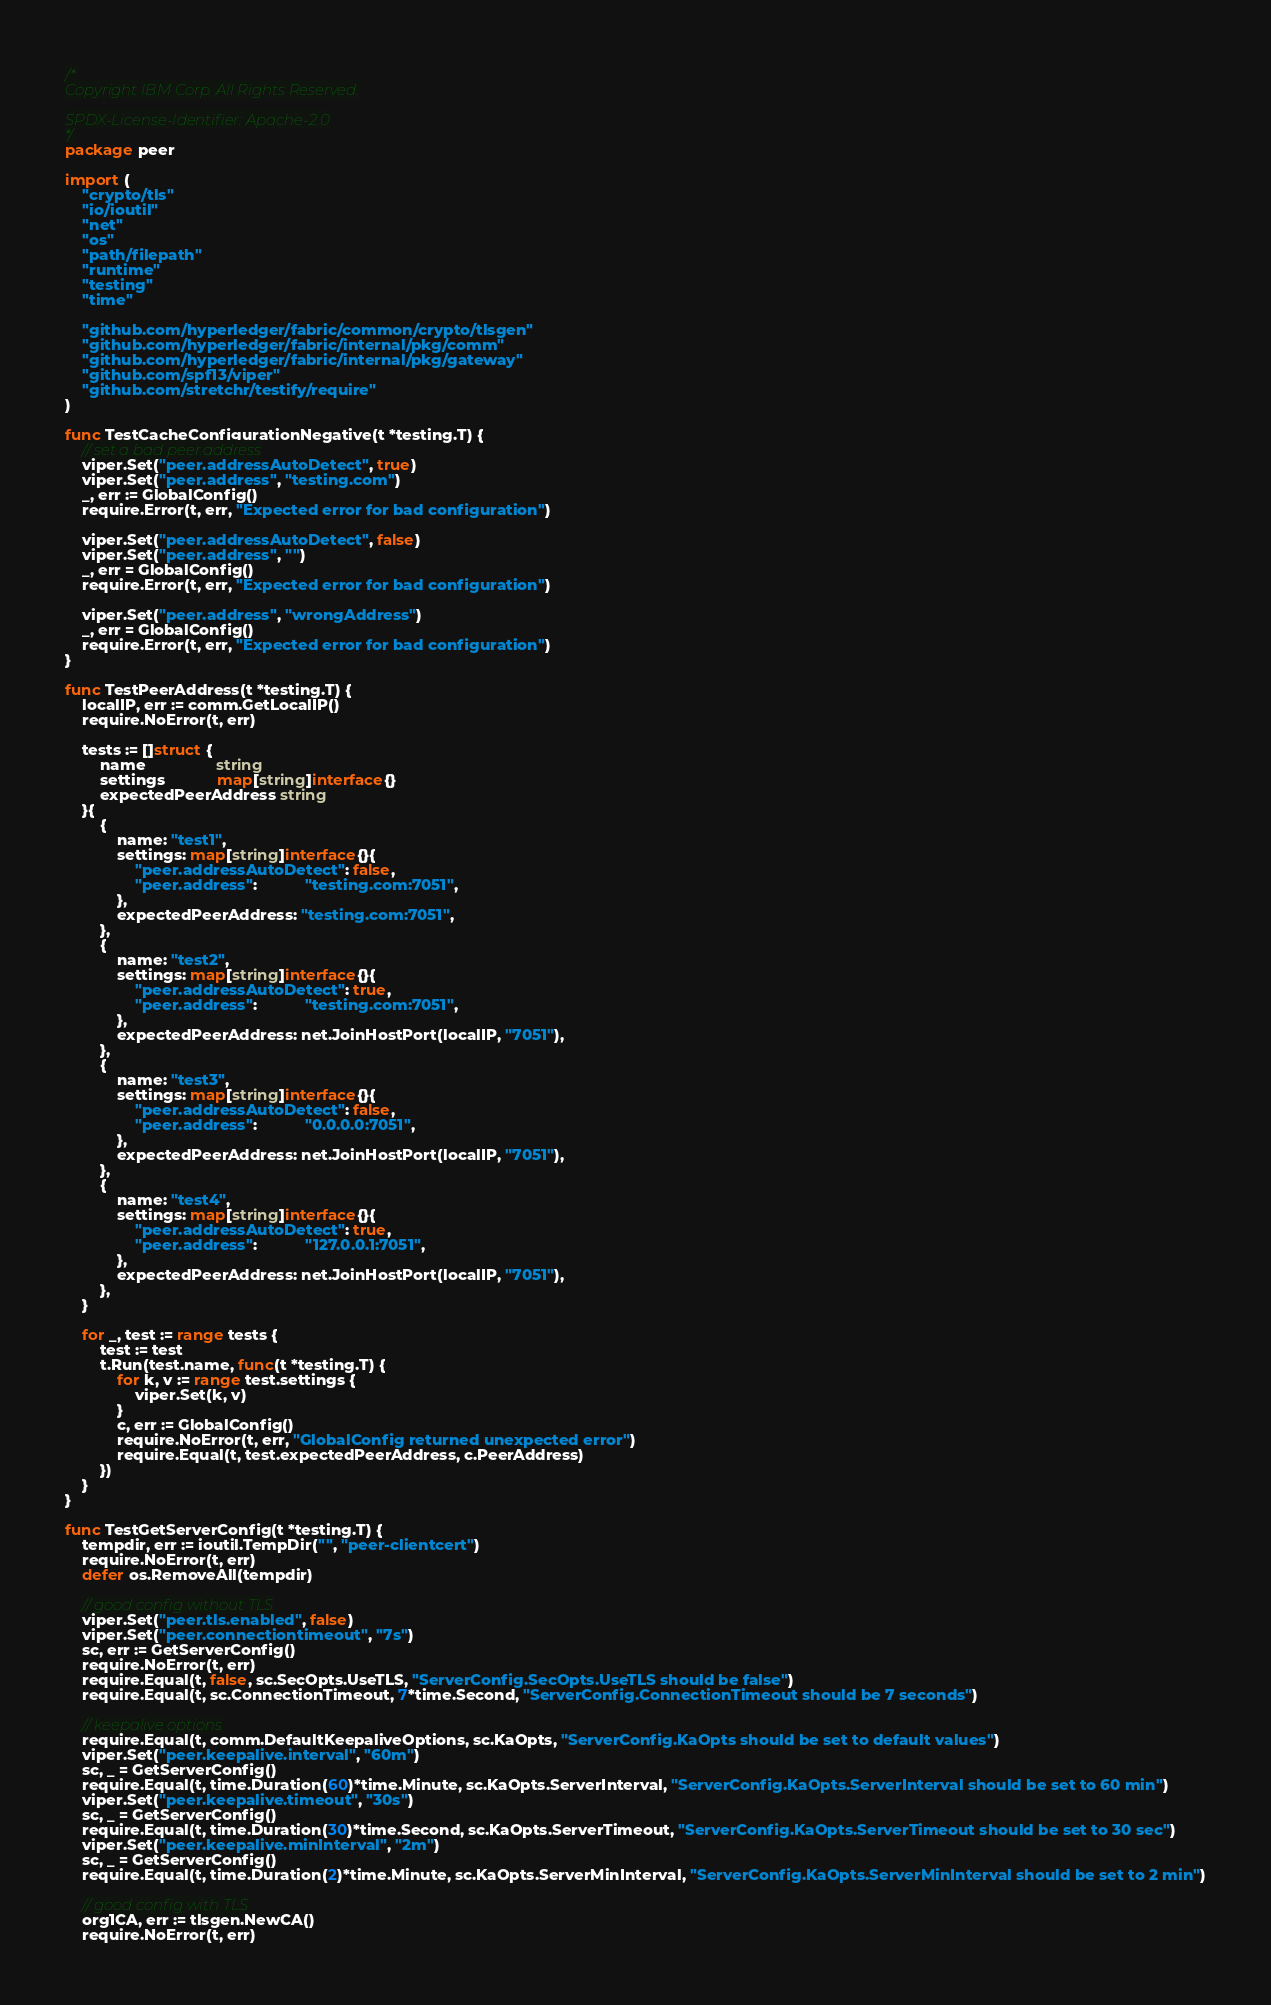<code> <loc_0><loc_0><loc_500><loc_500><_Go_>/*
Copyright IBM Corp. All Rights Reserved.

SPDX-License-Identifier: Apache-2.0
*/
package peer

import (
	"crypto/tls"
	"io/ioutil"
	"net"
	"os"
	"path/filepath"
	"runtime"
	"testing"
	"time"

	"github.com/hyperledger/fabric/common/crypto/tlsgen"
	"github.com/hyperledger/fabric/internal/pkg/comm"
	"github.com/hyperledger/fabric/internal/pkg/gateway"
	"github.com/spf13/viper"
	"github.com/stretchr/testify/require"
)

func TestCacheConfigurationNegative(t *testing.T) {
	// set a bad peer.address
	viper.Set("peer.addressAutoDetect", true)
	viper.Set("peer.address", "testing.com")
	_, err := GlobalConfig()
	require.Error(t, err, "Expected error for bad configuration")

	viper.Set("peer.addressAutoDetect", false)
	viper.Set("peer.address", "")
	_, err = GlobalConfig()
	require.Error(t, err, "Expected error for bad configuration")

	viper.Set("peer.address", "wrongAddress")
	_, err = GlobalConfig()
	require.Error(t, err, "Expected error for bad configuration")
}

func TestPeerAddress(t *testing.T) {
	localIP, err := comm.GetLocalIP()
	require.NoError(t, err)

	tests := []struct {
		name                string
		settings            map[string]interface{}
		expectedPeerAddress string
	}{
		{
			name: "test1",
			settings: map[string]interface{}{
				"peer.addressAutoDetect": false,
				"peer.address":           "testing.com:7051",
			},
			expectedPeerAddress: "testing.com:7051",
		},
		{
			name: "test2",
			settings: map[string]interface{}{
				"peer.addressAutoDetect": true,
				"peer.address":           "testing.com:7051",
			},
			expectedPeerAddress: net.JoinHostPort(localIP, "7051"),
		},
		{
			name: "test3",
			settings: map[string]interface{}{
				"peer.addressAutoDetect": false,
				"peer.address":           "0.0.0.0:7051",
			},
			expectedPeerAddress: net.JoinHostPort(localIP, "7051"),
		},
		{
			name: "test4",
			settings: map[string]interface{}{
				"peer.addressAutoDetect": true,
				"peer.address":           "127.0.0.1:7051",
			},
			expectedPeerAddress: net.JoinHostPort(localIP, "7051"),
		},
	}

	for _, test := range tests {
		test := test
		t.Run(test.name, func(t *testing.T) {
			for k, v := range test.settings {
				viper.Set(k, v)
			}
			c, err := GlobalConfig()
			require.NoError(t, err, "GlobalConfig returned unexpected error")
			require.Equal(t, test.expectedPeerAddress, c.PeerAddress)
		})
	}
}

func TestGetServerConfig(t *testing.T) {
	tempdir, err := ioutil.TempDir("", "peer-clientcert")
	require.NoError(t, err)
	defer os.RemoveAll(tempdir)

	// good config without TLS
	viper.Set("peer.tls.enabled", false)
	viper.Set("peer.connectiontimeout", "7s")
	sc, err := GetServerConfig()
	require.NoError(t, err)
	require.Equal(t, false, sc.SecOpts.UseTLS, "ServerConfig.SecOpts.UseTLS should be false")
	require.Equal(t, sc.ConnectionTimeout, 7*time.Second, "ServerConfig.ConnectionTimeout should be 7 seconds")

	// keepalive options
	require.Equal(t, comm.DefaultKeepaliveOptions, sc.KaOpts, "ServerConfig.KaOpts should be set to default values")
	viper.Set("peer.keepalive.interval", "60m")
	sc, _ = GetServerConfig()
	require.Equal(t, time.Duration(60)*time.Minute, sc.KaOpts.ServerInterval, "ServerConfig.KaOpts.ServerInterval should be set to 60 min")
	viper.Set("peer.keepalive.timeout", "30s")
	sc, _ = GetServerConfig()
	require.Equal(t, time.Duration(30)*time.Second, sc.KaOpts.ServerTimeout, "ServerConfig.KaOpts.ServerTimeout should be set to 30 sec")
	viper.Set("peer.keepalive.minInterval", "2m")
	sc, _ = GetServerConfig()
	require.Equal(t, time.Duration(2)*time.Minute, sc.KaOpts.ServerMinInterval, "ServerConfig.KaOpts.ServerMinInterval should be set to 2 min")

	// good config with TLS
	org1CA, err := tlsgen.NewCA()
	require.NoError(t, err)</code> 